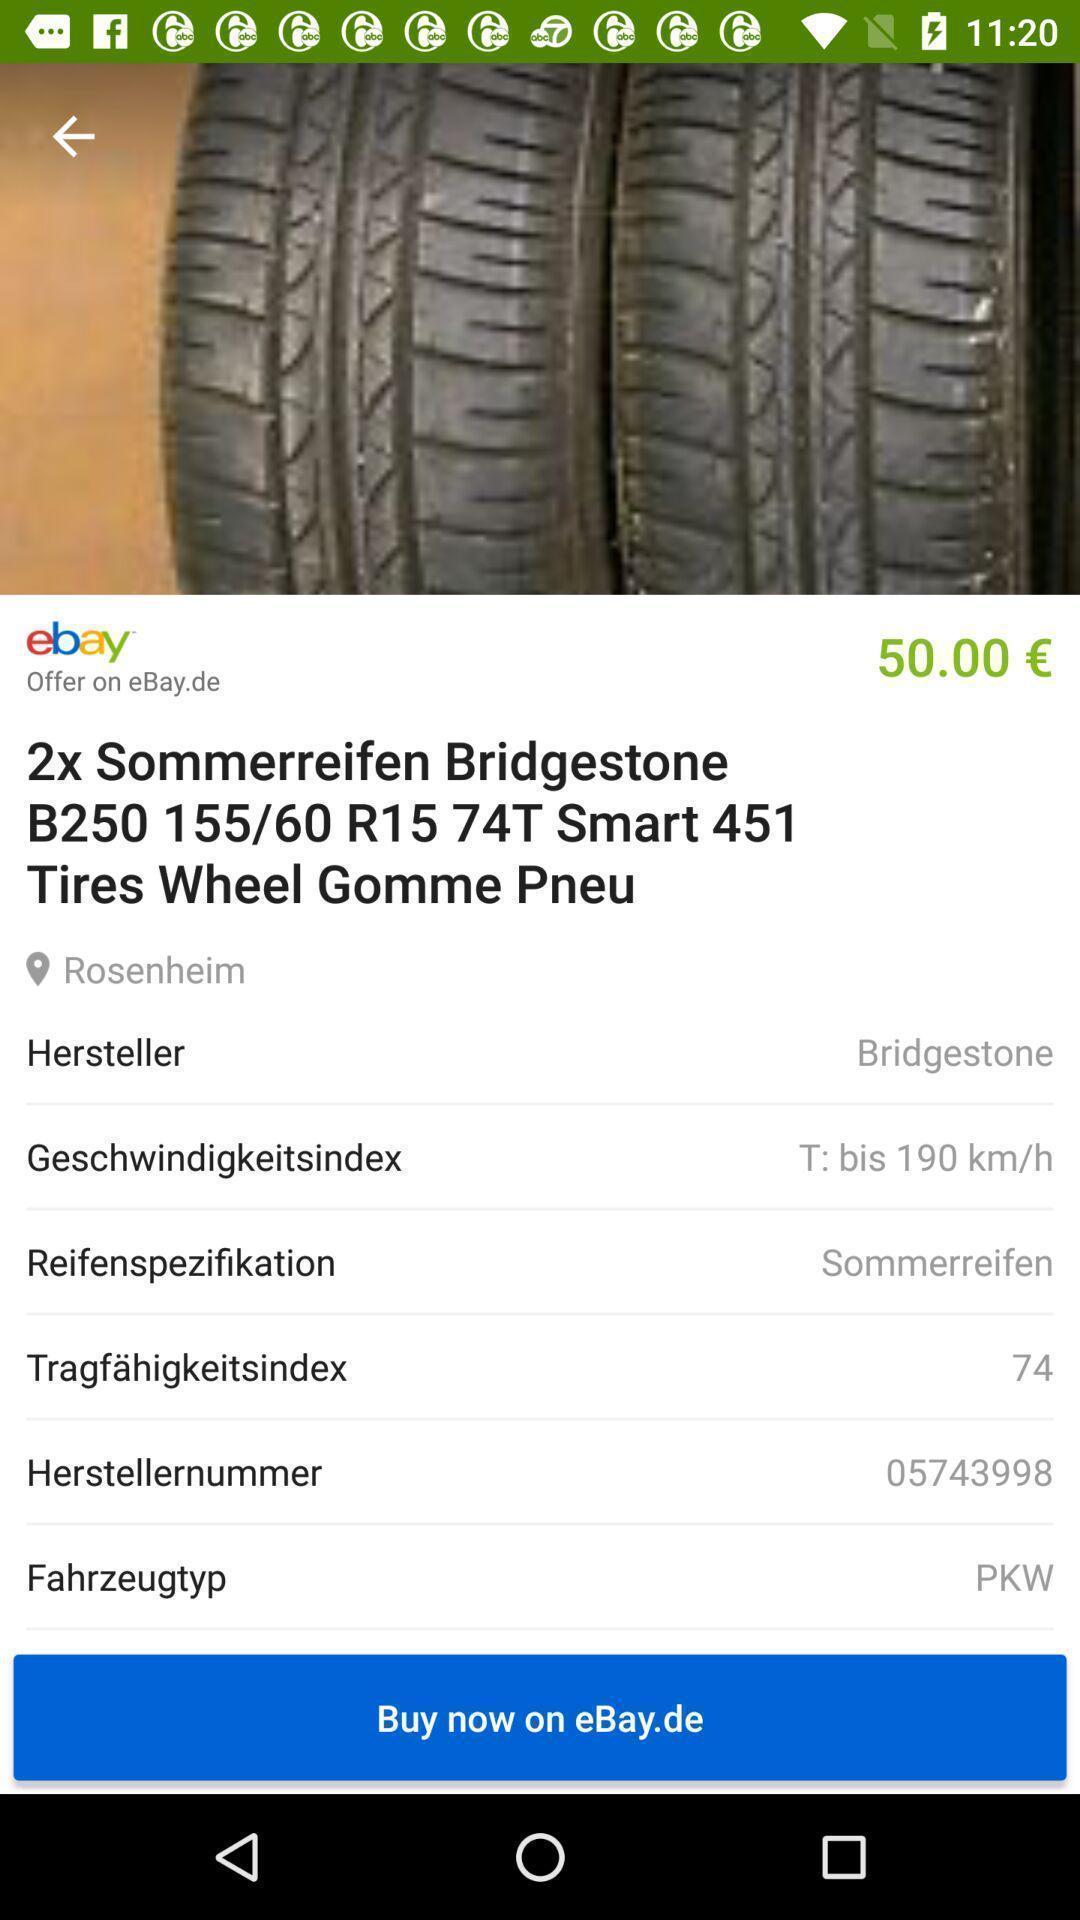Please provide a description for this image. Screen displays summary of a car. 